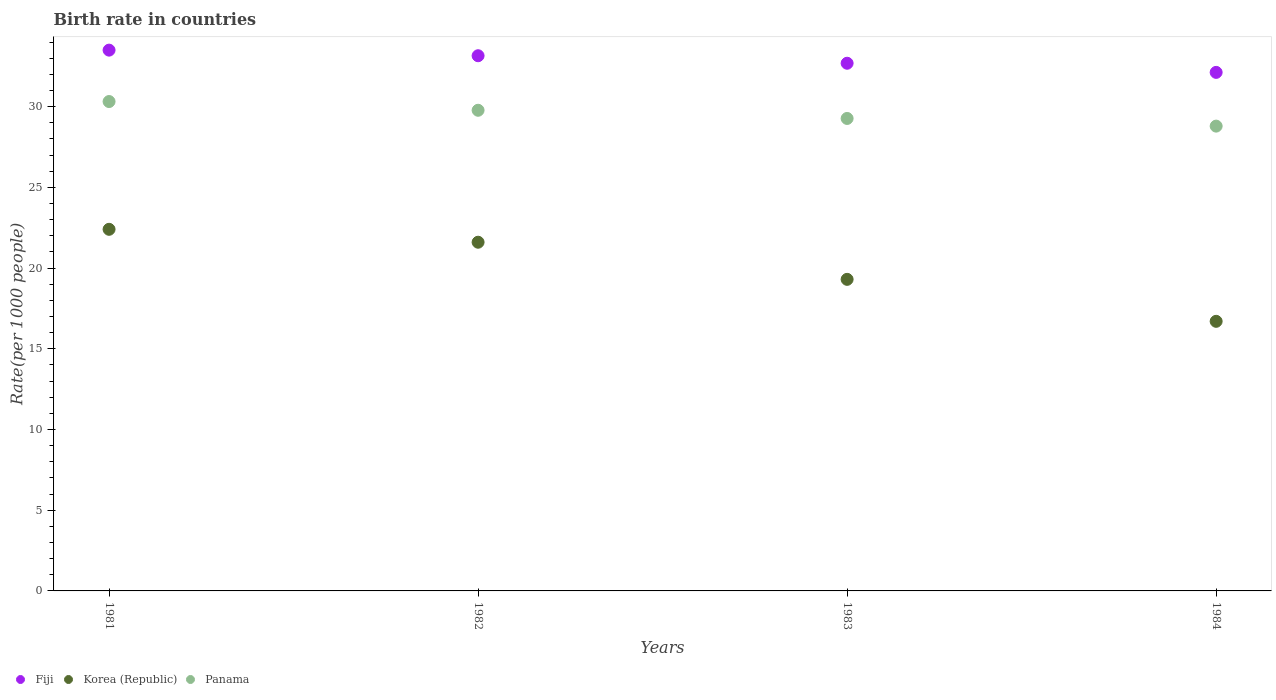How many different coloured dotlines are there?
Offer a terse response. 3. What is the birth rate in Fiji in 1982?
Ensure brevity in your answer.  33.15. Across all years, what is the maximum birth rate in Korea (Republic)?
Offer a terse response. 22.4. Across all years, what is the minimum birth rate in Panama?
Offer a terse response. 28.79. In which year was the birth rate in Fiji minimum?
Your answer should be very brief. 1984. What is the total birth rate in Fiji in the graph?
Offer a very short reply. 131.46. What is the difference between the birth rate in Fiji in 1982 and that in 1984?
Keep it short and to the point. 1.03. What is the difference between the birth rate in Fiji in 1984 and the birth rate in Panama in 1982?
Offer a terse response. 2.35. What is the average birth rate in Panama per year?
Keep it short and to the point. 29.54. In the year 1981, what is the difference between the birth rate in Korea (Republic) and birth rate in Fiji?
Your answer should be very brief. -11.1. In how many years, is the birth rate in Panama greater than 22?
Offer a terse response. 4. What is the ratio of the birth rate in Fiji in 1981 to that in 1983?
Your response must be concise. 1.02. Is the birth rate in Korea (Republic) in 1983 less than that in 1984?
Keep it short and to the point. No. What is the difference between the highest and the second highest birth rate in Panama?
Provide a succinct answer. 0.54. What is the difference between the highest and the lowest birth rate in Fiji?
Your answer should be very brief. 1.38. In how many years, is the birth rate in Korea (Republic) greater than the average birth rate in Korea (Republic) taken over all years?
Your answer should be very brief. 2. Is it the case that in every year, the sum of the birth rate in Korea (Republic) and birth rate in Panama  is greater than the birth rate in Fiji?
Your response must be concise. Yes. Is the birth rate in Panama strictly greater than the birth rate in Fiji over the years?
Provide a short and direct response. No. Is the birth rate in Fiji strictly less than the birth rate in Panama over the years?
Your answer should be very brief. No. How many years are there in the graph?
Make the answer very short. 4. What is the difference between two consecutive major ticks on the Y-axis?
Keep it short and to the point. 5. Are the values on the major ticks of Y-axis written in scientific E-notation?
Your response must be concise. No. Where does the legend appear in the graph?
Your answer should be very brief. Bottom left. How many legend labels are there?
Give a very brief answer. 3. What is the title of the graph?
Offer a terse response. Birth rate in countries. What is the label or title of the Y-axis?
Ensure brevity in your answer.  Rate(per 1000 people). What is the Rate(per 1000 people) of Fiji in 1981?
Make the answer very short. 33.5. What is the Rate(per 1000 people) of Korea (Republic) in 1981?
Provide a short and direct response. 22.4. What is the Rate(per 1000 people) in Panama in 1981?
Provide a short and direct response. 30.32. What is the Rate(per 1000 people) in Fiji in 1982?
Make the answer very short. 33.15. What is the Rate(per 1000 people) of Korea (Republic) in 1982?
Your response must be concise. 21.6. What is the Rate(per 1000 people) in Panama in 1982?
Your answer should be compact. 29.77. What is the Rate(per 1000 people) in Fiji in 1983?
Offer a very short reply. 32.69. What is the Rate(per 1000 people) in Korea (Republic) in 1983?
Your answer should be compact. 19.3. What is the Rate(per 1000 people) of Panama in 1983?
Provide a short and direct response. 29.27. What is the Rate(per 1000 people) of Fiji in 1984?
Keep it short and to the point. 32.12. What is the Rate(per 1000 people) in Panama in 1984?
Your answer should be compact. 28.79. Across all years, what is the maximum Rate(per 1000 people) of Fiji?
Offer a very short reply. 33.5. Across all years, what is the maximum Rate(per 1000 people) in Korea (Republic)?
Your answer should be compact. 22.4. Across all years, what is the maximum Rate(per 1000 people) of Panama?
Ensure brevity in your answer.  30.32. Across all years, what is the minimum Rate(per 1000 people) of Fiji?
Your answer should be very brief. 32.12. Across all years, what is the minimum Rate(per 1000 people) of Korea (Republic)?
Ensure brevity in your answer.  16.7. Across all years, what is the minimum Rate(per 1000 people) in Panama?
Your answer should be very brief. 28.79. What is the total Rate(per 1000 people) of Fiji in the graph?
Offer a terse response. 131.46. What is the total Rate(per 1000 people) in Panama in the graph?
Your answer should be compact. 118.15. What is the difference between the Rate(per 1000 people) of Fiji in 1981 and that in 1982?
Your answer should be compact. 0.35. What is the difference between the Rate(per 1000 people) of Panama in 1981 and that in 1982?
Make the answer very short. 0.54. What is the difference between the Rate(per 1000 people) of Fiji in 1981 and that in 1983?
Offer a very short reply. 0.81. What is the difference between the Rate(per 1000 people) of Panama in 1981 and that in 1983?
Provide a short and direct response. 1.05. What is the difference between the Rate(per 1000 people) of Fiji in 1981 and that in 1984?
Provide a short and direct response. 1.38. What is the difference between the Rate(per 1000 people) of Panama in 1981 and that in 1984?
Your answer should be very brief. 1.52. What is the difference between the Rate(per 1000 people) of Fiji in 1982 and that in 1983?
Ensure brevity in your answer.  0.47. What is the difference between the Rate(per 1000 people) in Panama in 1982 and that in 1983?
Your answer should be compact. 0.51. What is the difference between the Rate(per 1000 people) in Fiji in 1982 and that in 1984?
Keep it short and to the point. 1.03. What is the difference between the Rate(per 1000 people) in Korea (Republic) in 1982 and that in 1984?
Provide a succinct answer. 4.9. What is the difference between the Rate(per 1000 people) in Panama in 1982 and that in 1984?
Your response must be concise. 0.98. What is the difference between the Rate(per 1000 people) in Fiji in 1983 and that in 1984?
Your answer should be very brief. 0.57. What is the difference between the Rate(per 1000 people) in Panama in 1983 and that in 1984?
Your answer should be very brief. 0.47. What is the difference between the Rate(per 1000 people) of Fiji in 1981 and the Rate(per 1000 people) of Korea (Republic) in 1982?
Provide a short and direct response. 11.9. What is the difference between the Rate(per 1000 people) in Fiji in 1981 and the Rate(per 1000 people) in Panama in 1982?
Your answer should be compact. 3.73. What is the difference between the Rate(per 1000 people) in Korea (Republic) in 1981 and the Rate(per 1000 people) in Panama in 1982?
Keep it short and to the point. -7.37. What is the difference between the Rate(per 1000 people) of Fiji in 1981 and the Rate(per 1000 people) of Korea (Republic) in 1983?
Your answer should be very brief. 14.2. What is the difference between the Rate(per 1000 people) of Fiji in 1981 and the Rate(per 1000 people) of Panama in 1983?
Your answer should be compact. 4.23. What is the difference between the Rate(per 1000 people) in Korea (Republic) in 1981 and the Rate(per 1000 people) in Panama in 1983?
Your response must be concise. -6.87. What is the difference between the Rate(per 1000 people) in Fiji in 1981 and the Rate(per 1000 people) in Korea (Republic) in 1984?
Your answer should be compact. 16.8. What is the difference between the Rate(per 1000 people) of Fiji in 1981 and the Rate(per 1000 people) of Panama in 1984?
Give a very brief answer. 4.71. What is the difference between the Rate(per 1000 people) in Korea (Republic) in 1981 and the Rate(per 1000 people) in Panama in 1984?
Keep it short and to the point. -6.39. What is the difference between the Rate(per 1000 people) in Fiji in 1982 and the Rate(per 1000 people) in Korea (Republic) in 1983?
Provide a succinct answer. 13.85. What is the difference between the Rate(per 1000 people) of Fiji in 1982 and the Rate(per 1000 people) of Panama in 1983?
Your answer should be very brief. 3.88. What is the difference between the Rate(per 1000 people) of Korea (Republic) in 1982 and the Rate(per 1000 people) of Panama in 1983?
Keep it short and to the point. -7.67. What is the difference between the Rate(per 1000 people) in Fiji in 1982 and the Rate(per 1000 people) in Korea (Republic) in 1984?
Provide a succinct answer. 16.45. What is the difference between the Rate(per 1000 people) of Fiji in 1982 and the Rate(per 1000 people) of Panama in 1984?
Provide a succinct answer. 4.36. What is the difference between the Rate(per 1000 people) in Korea (Republic) in 1982 and the Rate(per 1000 people) in Panama in 1984?
Your answer should be compact. -7.19. What is the difference between the Rate(per 1000 people) of Fiji in 1983 and the Rate(per 1000 people) of Korea (Republic) in 1984?
Your answer should be compact. 15.99. What is the difference between the Rate(per 1000 people) in Fiji in 1983 and the Rate(per 1000 people) in Panama in 1984?
Offer a very short reply. 3.9. What is the difference between the Rate(per 1000 people) in Korea (Republic) in 1983 and the Rate(per 1000 people) in Panama in 1984?
Your response must be concise. -9.49. What is the average Rate(per 1000 people) in Fiji per year?
Your answer should be compact. 32.86. What is the average Rate(per 1000 people) in Panama per year?
Your response must be concise. 29.54. In the year 1981, what is the difference between the Rate(per 1000 people) of Fiji and Rate(per 1000 people) of Korea (Republic)?
Ensure brevity in your answer.  11.1. In the year 1981, what is the difference between the Rate(per 1000 people) of Fiji and Rate(per 1000 people) of Panama?
Your answer should be very brief. 3.18. In the year 1981, what is the difference between the Rate(per 1000 people) in Korea (Republic) and Rate(per 1000 people) in Panama?
Offer a very short reply. -7.92. In the year 1982, what is the difference between the Rate(per 1000 people) in Fiji and Rate(per 1000 people) in Korea (Republic)?
Your response must be concise. 11.55. In the year 1982, what is the difference between the Rate(per 1000 people) in Fiji and Rate(per 1000 people) in Panama?
Your response must be concise. 3.38. In the year 1982, what is the difference between the Rate(per 1000 people) in Korea (Republic) and Rate(per 1000 people) in Panama?
Provide a short and direct response. -8.17. In the year 1983, what is the difference between the Rate(per 1000 people) of Fiji and Rate(per 1000 people) of Korea (Republic)?
Keep it short and to the point. 13.39. In the year 1983, what is the difference between the Rate(per 1000 people) of Fiji and Rate(per 1000 people) of Panama?
Ensure brevity in your answer.  3.42. In the year 1983, what is the difference between the Rate(per 1000 people) in Korea (Republic) and Rate(per 1000 people) in Panama?
Your answer should be very brief. -9.97. In the year 1984, what is the difference between the Rate(per 1000 people) in Fiji and Rate(per 1000 people) in Korea (Republic)?
Keep it short and to the point. 15.42. In the year 1984, what is the difference between the Rate(per 1000 people) of Fiji and Rate(per 1000 people) of Panama?
Your answer should be very brief. 3.33. In the year 1984, what is the difference between the Rate(per 1000 people) in Korea (Republic) and Rate(per 1000 people) in Panama?
Give a very brief answer. -12.09. What is the ratio of the Rate(per 1000 people) of Fiji in 1981 to that in 1982?
Your response must be concise. 1.01. What is the ratio of the Rate(per 1000 people) in Korea (Republic) in 1981 to that in 1982?
Keep it short and to the point. 1.04. What is the ratio of the Rate(per 1000 people) in Panama in 1981 to that in 1982?
Provide a succinct answer. 1.02. What is the ratio of the Rate(per 1000 people) in Fiji in 1981 to that in 1983?
Your answer should be very brief. 1.02. What is the ratio of the Rate(per 1000 people) of Korea (Republic) in 1981 to that in 1983?
Your response must be concise. 1.16. What is the ratio of the Rate(per 1000 people) of Panama in 1981 to that in 1983?
Ensure brevity in your answer.  1.04. What is the ratio of the Rate(per 1000 people) in Fiji in 1981 to that in 1984?
Provide a short and direct response. 1.04. What is the ratio of the Rate(per 1000 people) of Korea (Republic) in 1981 to that in 1984?
Offer a very short reply. 1.34. What is the ratio of the Rate(per 1000 people) of Panama in 1981 to that in 1984?
Give a very brief answer. 1.05. What is the ratio of the Rate(per 1000 people) in Fiji in 1982 to that in 1983?
Your answer should be compact. 1.01. What is the ratio of the Rate(per 1000 people) of Korea (Republic) in 1982 to that in 1983?
Provide a short and direct response. 1.12. What is the ratio of the Rate(per 1000 people) of Panama in 1982 to that in 1983?
Offer a very short reply. 1.02. What is the ratio of the Rate(per 1000 people) in Fiji in 1982 to that in 1984?
Keep it short and to the point. 1.03. What is the ratio of the Rate(per 1000 people) of Korea (Republic) in 1982 to that in 1984?
Keep it short and to the point. 1.29. What is the ratio of the Rate(per 1000 people) in Panama in 1982 to that in 1984?
Give a very brief answer. 1.03. What is the ratio of the Rate(per 1000 people) in Fiji in 1983 to that in 1984?
Your response must be concise. 1.02. What is the ratio of the Rate(per 1000 people) in Korea (Republic) in 1983 to that in 1984?
Provide a succinct answer. 1.16. What is the ratio of the Rate(per 1000 people) in Panama in 1983 to that in 1984?
Your answer should be very brief. 1.02. What is the difference between the highest and the second highest Rate(per 1000 people) of Fiji?
Provide a short and direct response. 0.35. What is the difference between the highest and the second highest Rate(per 1000 people) of Panama?
Your response must be concise. 0.54. What is the difference between the highest and the lowest Rate(per 1000 people) of Fiji?
Your answer should be compact. 1.38. What is the difference between the highest and the lowest Rate(per 1000 people) of Korea (Republic)?
Provide a short and direct response. 5.7. What is the difference between the highest and the lowest Rate(per 1000 people) of Panama?
Provide a short and direct response. 1.52. 